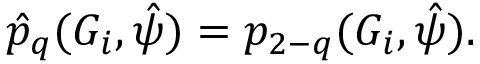Convert formula to latex. <formula><loc_0><loc_0><loc_500><loc_500>\hat { p } _ { q } ( G _ { i } , \hat { \psi } ) = p _ { 2 - q } ( G _ { i } , \hat { \psi } ) .</formula> 